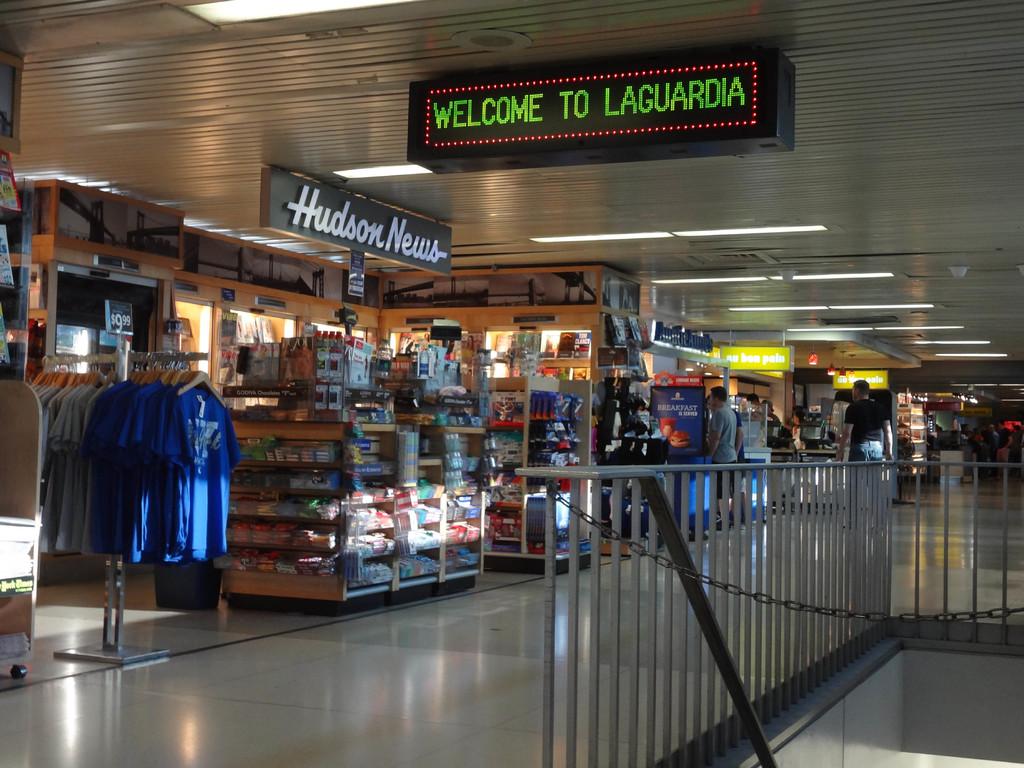Where are we being welcomed?
Provide a succinct answer. Laguardia. What is the name of the store to the left?
Give a very brief answer. Hudson news. 